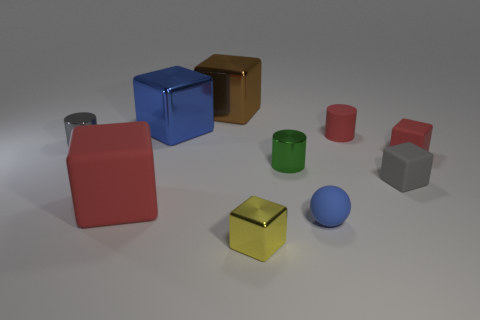There is a matte cylinder; is it the same color as the small matte block behind the small green cylinder?
Provide a succinct answer. Yes. Is there a gray cube that has the same size as the green cylinder?
Keep it short and to the point. Yes. There is a object that is the same color as the tiny ball; what is its size?
Keep it short and to the point. Large. There is a tiny yellow object in front of the big red thing; what material is it?
Ensure brevity in your answer.  Metal. Are there an equal number of tiny spheres that are to the left of the tiny shiny cube and small objects to the right of the blue ball?
Your answer should be compact. No. Do the red rubber cube on the right side of the big brown metal object and the blue thing in front of the small rubber cylinder have the same size?
Offer a terse response. Yes. How many small cylinders have the same color as the sphere?
Ensure brevity in your answer.  0. What is the material of the tiny cylinder that is the same color as the big matte object?
Your answer should be very brief. Rubber. Are there more red objects left of the red matte cylinder than tiny purple matte cylinders?
Provide a succinct answer. Yes. Is the big brown thing the same shape as the tiny gray rubber thing?
Make the answer very short. Yes. 